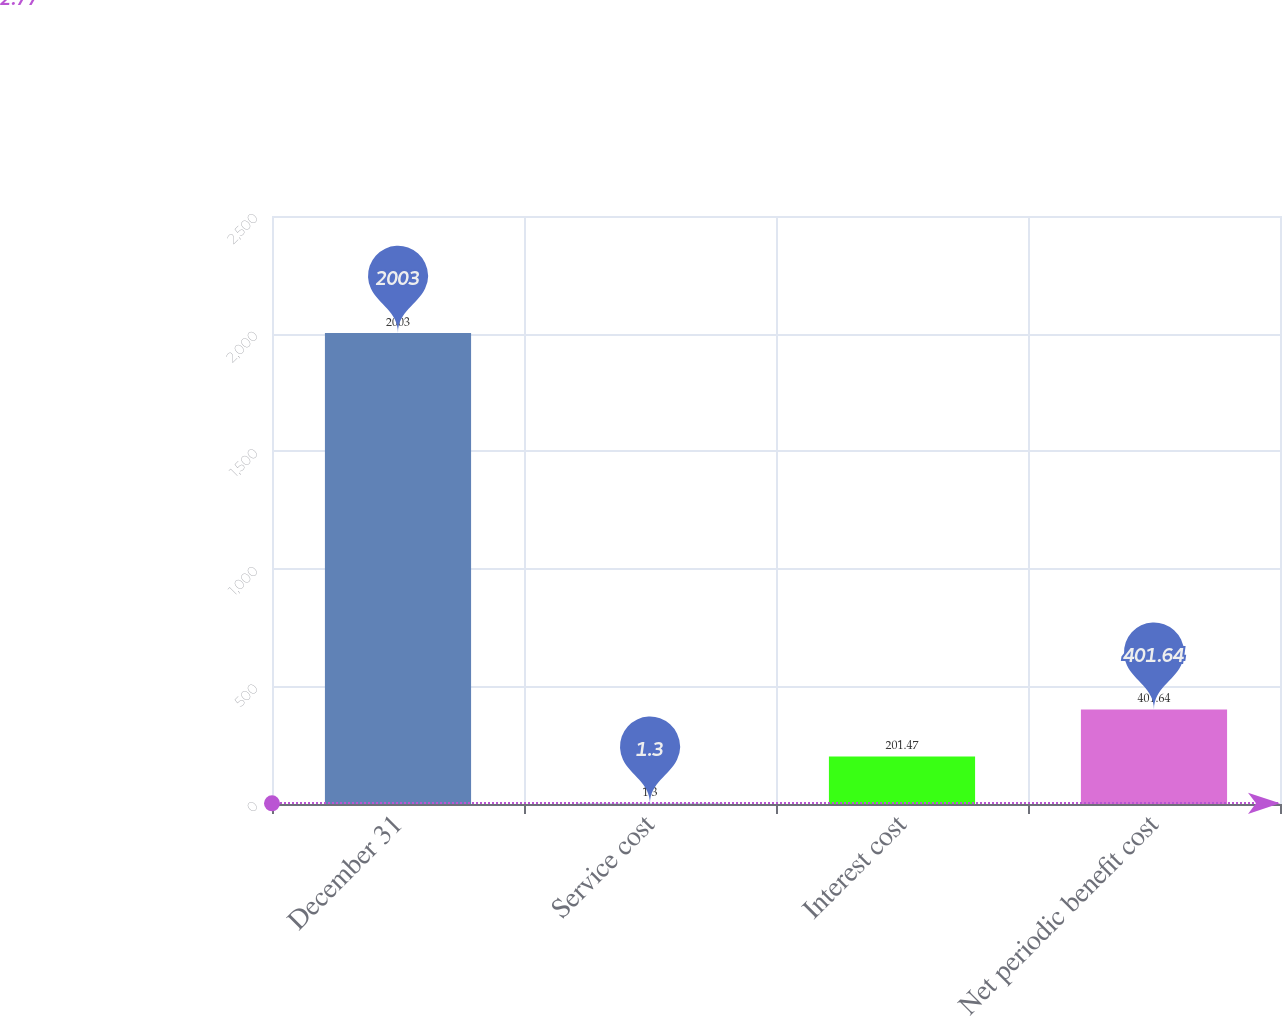Convert chart. <chart><loc_0><loc_0><loc_500><loc_500><bar_chart><fcel>December 31<fcel>Service cost<fcel>Interest cost<fcel>Net periodic benefit cost<nl><fcel>2003<fcel>1.3<fcel>201.47<fcel>401.64<nl></chart> 